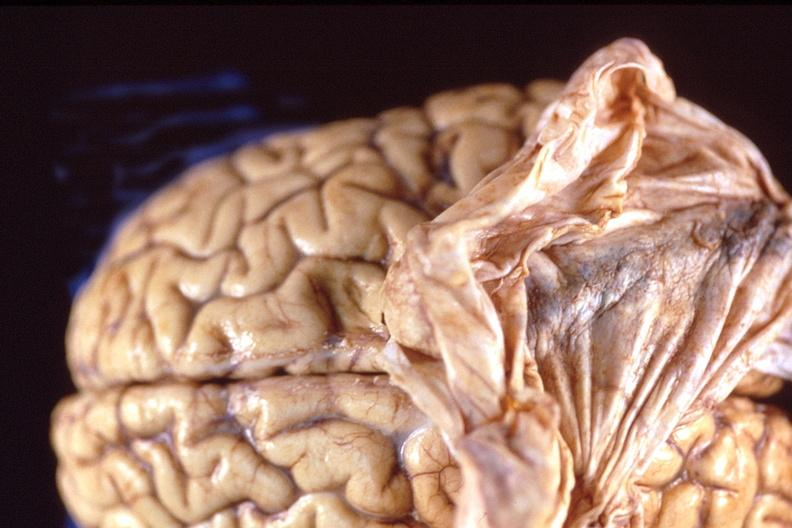does this image show brain, breast cancer metastasis to meninges?
Answer the question using a single word or phrase. Yes 